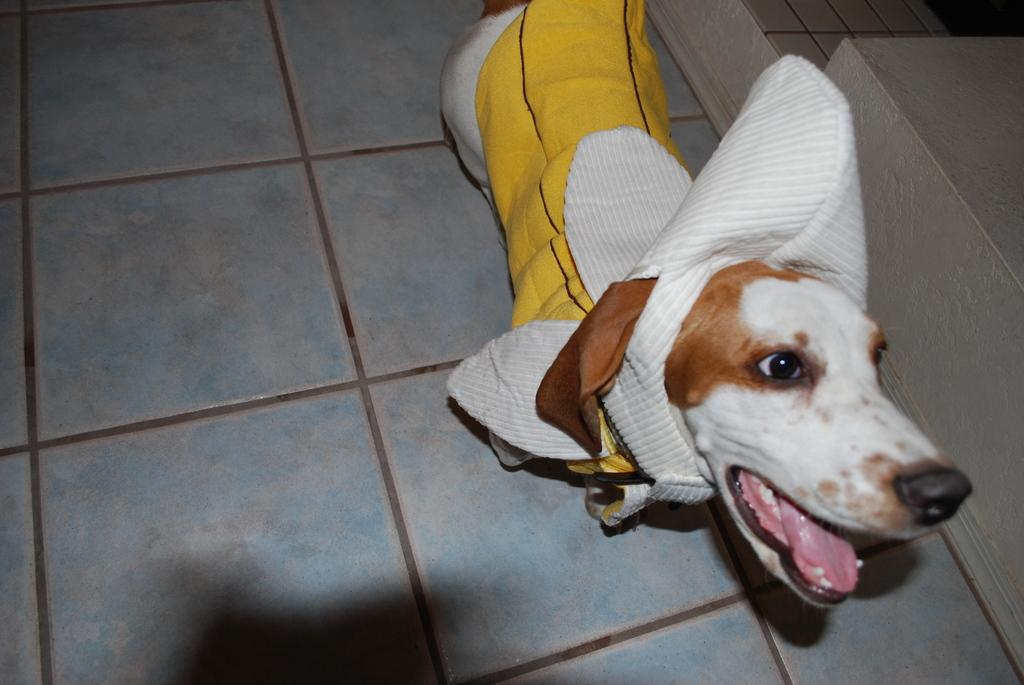What animal is present in the image? There is a dog in the image. What is the dog wearing? The dog is wearing a yellow and white cloth. How many clams can be seen in the image? There are no clams present in the image; it features a dog wearing a yellow and white cloth. What type of calculator is the dog using in the image? There is no calculator present in the image; it features a dog wearing a yellow and white cloth. 